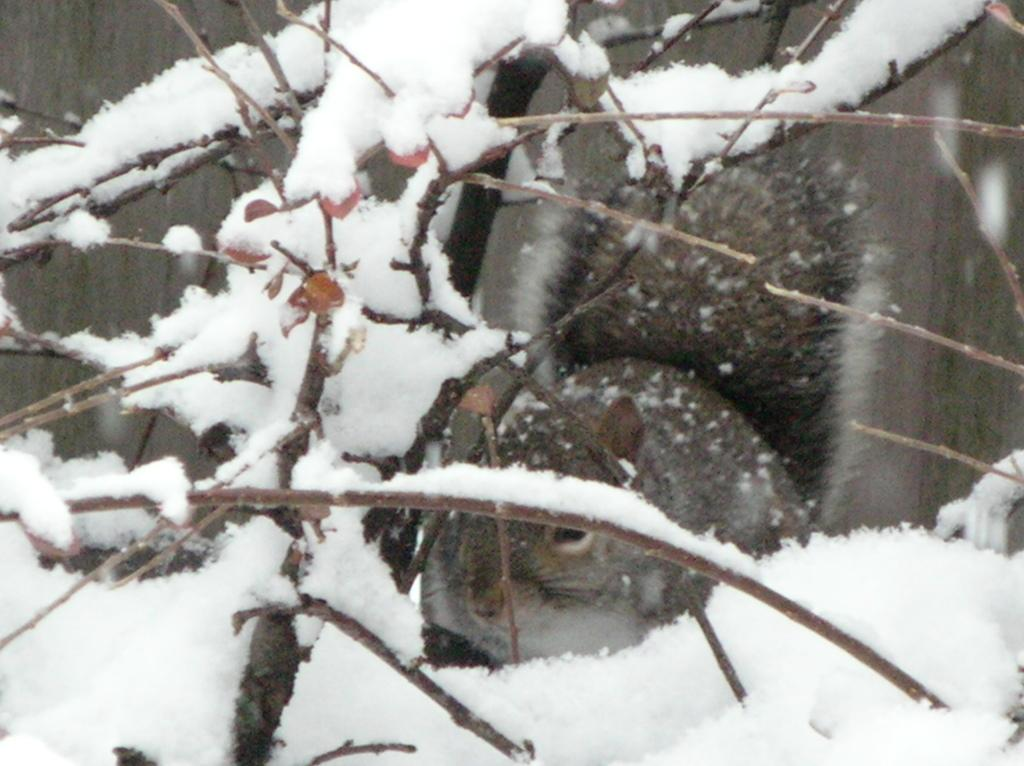What is present in the foreground of the image? In the foreground of the image, there is snow, leaves, stems, and a squirrel. Can you describe the squirrel's surroundings in the image? The squirrel is surrounded by snow, leaves, and stems in the foreground of the image. What can be observed about the background of the image? The background of the image is blurred. What hobbies does the squirrel's family engage in, as seen in the image? There is no information about the squirrel's family or their hobbies in the image. Can you describe the nest of the squirrel in the image? There is no nest visible in the image; it only shows the squirrel, snow, leaves, and stems in the foreground. 